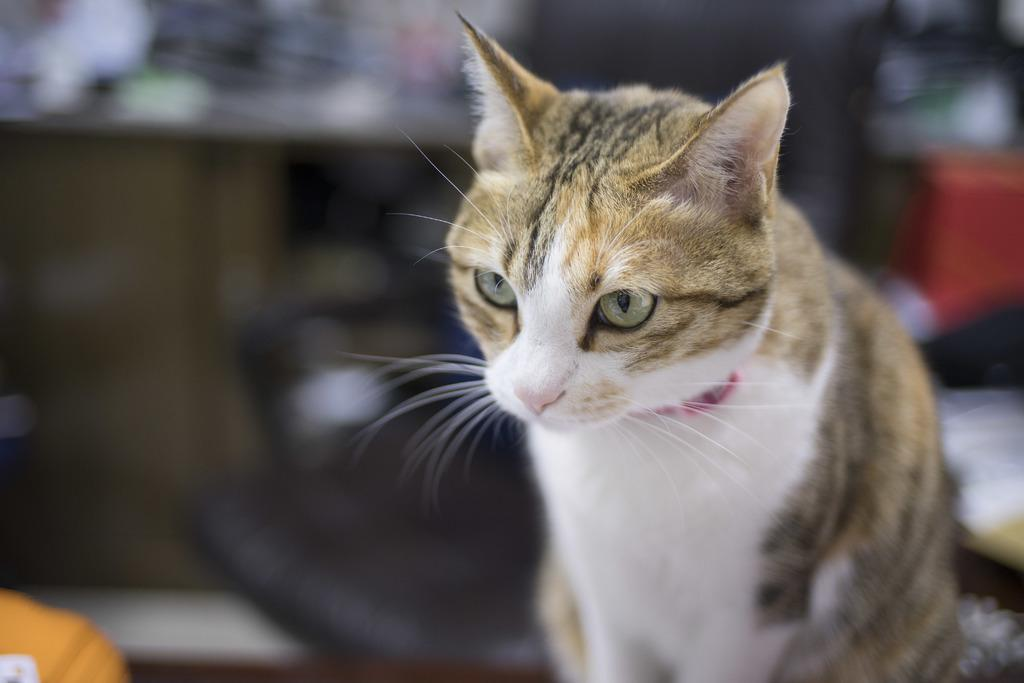What type of animal is present in the image? There is a cat in the image. What type of cub can be seen playing with the cat in the image? There is no cub present in the image, and the cat is not shown playing with any other animals. 